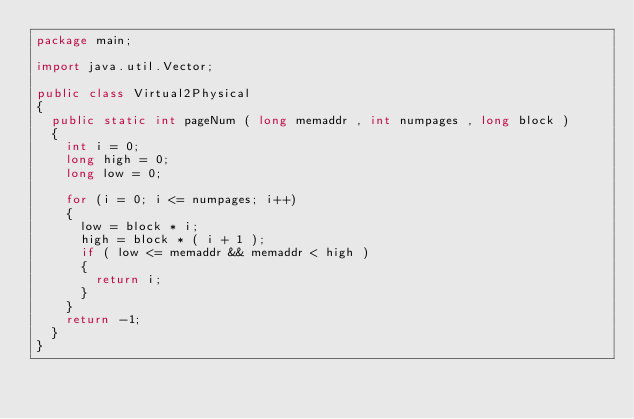<code> <loc_0><loc_0><loc_500><loc_500><_Java_>package main;

import java.util.Vector;

public class Virtual2Physical 
{
  public static int pageNum ( long memaddr , int numpages , long block ) 
  {
    int i = 0;
    long high = 0;
    long low = 0;
    
    for (i = 0; i <= numpages; i++) 
    {
      low = block * i;
      high = block * ( i + 1 ); 
      if ( low <= memaddr && memaddr < high ) 
      {
        return i;
      }
    } 
    return -1;
  }
}
</code> 